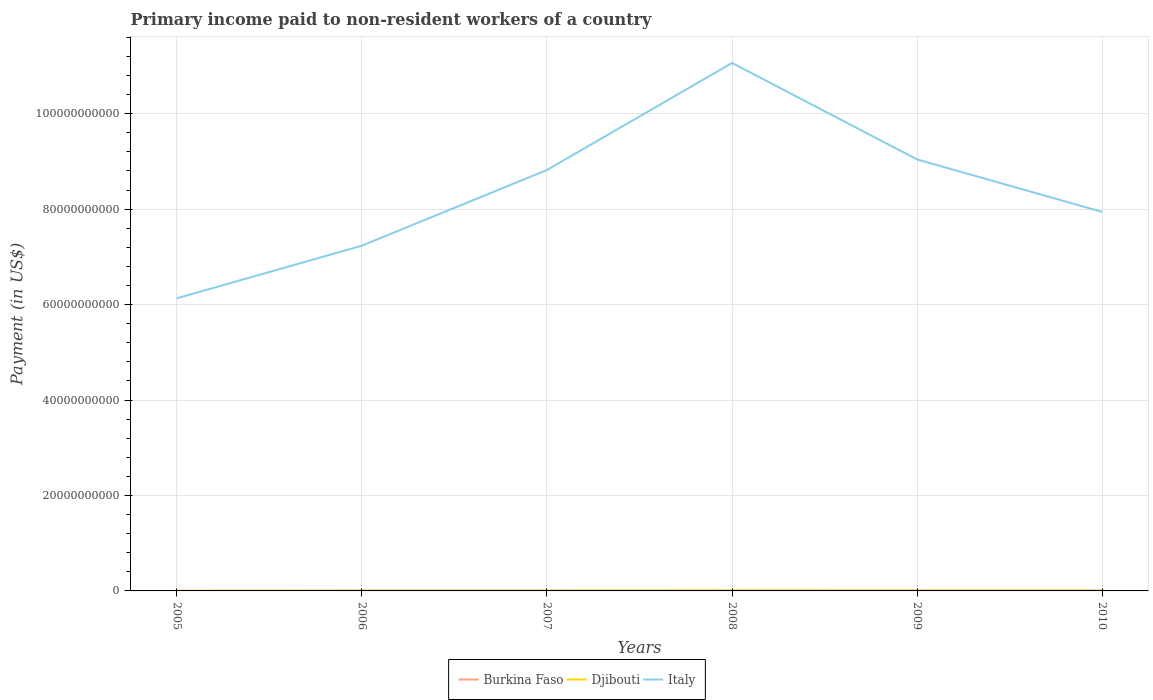How many different coloured lines are there?
Make the answer very short. 3. Across all years, what is the maximum amount paid to workers in Burkina Faso?
Your response must be concise. 3.80e+07. What is the total amount paid to workers in Burkina Faso in the graph?
Provide a short and direct response. -2.83e+07. What is the difference between the highest and the second highest amount paid to workers in Burkina Faso?
Offer a terse response. 5.37e+07. What is the difference between the highest and the lowest amount paid to workers in Italy?
Ensure brevity in your answer.  3. How many years are there in the graph?
Provide a succinct answer. 6. Are the values on the major ticks of Y-axis written in scientific E-notation?
Offer a terse response. No. Does the graph contain grids?
Provide a short and direct response. Yes. Where does the legend appear in the graph?
Your response must be concise. Bottom center. How many legend labels are there?
Offer a very short reply. 3. What is the title of the graph?
Your response must be concise. Primary income paid to non-resident workers of a country. What is the label or title of the X-axis?
Your response must be concise. Years. What is the label or title of the Y-axis?
Your answer should be very brief. Payment (in US$). What is the Payment (in US$) of Burkina Faso in 2005?
Give a very brief answer. 3.80e+07. What is the Payment (in US$) in Djibouti in 2005?
Provide a succinct answer. 3.20e+07. What is the Payment (in US$) of Italy in 2005?
Provide a succinct answer. 6.13e+1. What is the Payment (in US$) of Burkina Faso in 2006?
Keep it short and to the point. 6.05e+07. What is the Payment (in US$) in Djibouti in 2006?
Your response must be concise. 3.49e+07. What is the Payment (in US$) of Italy in 2006?
Offer a very short reply. 7.24e+1. What is the Payment (in US$) in Burkina Faso in 2007?
Keep it short and to the point. 6.34e+07. What is the Payment (in US$) of Djibouti in 2007?
Provide a succinct answer. 3.52e+07. What is the Payment (in US$) in Italy in 2007?
Provide a succinct answer. 8.82e+1. What is the Payment (in US$) of Burkina Faso in 2008?
Offer a very short reply. 8.53e+07. What is the Payment (in US$) of Djibouti in 2008?
Your response must be concise. 4.56e+07. What is the Payment (in US$) of Italy in 2008?
Ensure brevity in your answer.  1.11e+11. What is the Payment (in US$) in Burkina Faso in 2009?
Keep it short and to the point. 8.74e+07. What is the Payment (in US$) of Djibouti in 2009?
Keep it short and to the point. 3.70e+07. What is the Payment (in US$) of Italy in 2009?
Your answer should be compact. 9.04e+1. What is the Payment (in US$) in Burkina Faso in 2010?
Your answer should be compact. 9.17e+07. What is the Payment (in US$) in Djibouti in 2010?
Provide a succinct answer. 3.28e+07. What is the Payment (in US$) in Italy in 2010?
Offer a terse response. 7.94e+1. Across all years, what is the maximum Payment (in US$) of Burkina Faso?
Your response must be concise. 9.17e+07. Across all years, what is the maximum Payment (in US$) in Djibouti?
Your response must be concise. 4.56e+07. Across all years, what is the maximum Payment (in US$) of Italy?
Give a very brief answer. 1.11e+11. Across all years, what is the minimum Payment (in US$) of Burkina Faso?
Ensure brevity in your answer.  3.80e+07. Across all years, what is the minimum Payment (in US$) of Djibouti?
Your answer should be very brief. 3.20e+07. Across all years, what is the minimum Payment (in US$) of Italy?
Provide a short and direct response. 6.13e+1. What is the total Payment (in US$) in Burkina Faso in the graph?
Your response must be concise. 4.26e+08. What is the total Payment (in US$) in Djibouti in the graph?
Your answer should be very brief. 2.17e+08. What is the total Payment (in US$) of Italy in the graph?
Provide a succinct answer. 5.02e+11. What is the difference between the Payment (in US$) of Burkina Faso in 2005 and that in 2006?
Offer a terse response. -2.25e+07. What is the difference between the Payment (in US$) in Djibouti in 2005 and that in 2006?
Offer a terse response. -2.91e+06. What is the difference between the Payment (in US$) of Italy in 2005 and that in 2006?
Offer a terse response. -1.10e+1. What is the difference between the Payment (in US$) in Burkina Faso in 2005 and that in 2007?
Offer a terse response. -2.54e+07. What is the difference between the Payment (in US$) in Djibouti in 2005 and that in 2007?
Your response must be concise. -3.24e+06. What is the difference between the Payment (in US$) of Italy in 2005 and that in 2007?
Keep it short and to the point. -2.69e+1. What is the difference between the Payment (in US$) of Burkina Faso in 2005 and that in 2008?
Provide a succinct answer. -4.73e+07. What is the difference between the Payment (in US$) of Djibouti in 2005 and that in 2008?
Provide a short and direct response. -1.36e+07. What is the difference between the Payment (in US$) in Italy in 2005 and that in 2008?
Give a very brief answer. -4.93e+1. What is the difference between the Payment (in US$) of Burkina Faso in 2005 and that in 2009?
Provide a succinct answer. -4.94e+07. What is the difference between the Payment (in US$) in Djibouti in 2005 and that in 2009?
Offer a terse response. -5.00e+06. What is the difference between the Payment (in US$) of Italy in 2005 and that in 2009?
Give a very brief answer. -2.91e+1. What is the difference between the Payment (in US$) of Burkina Faso in 2005 and that in 2010?
Provide a short and direct response. -5.37e+07. What is the difference between the Payment (in US$) of Djibouti in 2005 and that in 2010?
Your answer should be very brief. -7.99e+05. What is the difference between the Payment (in US$) of Italy in 2005 and that in 2010?
Ensure brevity in your answer.  -1.81e+1. What is the difference between the Payment (in US$) of Burkina Faso in 2006 and that in 2007?
Keep it short and to the point. -2.89e+06. What is the difference between the Payment (in US$) of Djibouti in 2006 and that in 2007?
Provide a succinct answer. -3.32e+05. What is the difference between the Payment (in US$) in Italy in 2006 and that in 2007?
Keep it short and to the point. -1.59e+1. What is the difference between the Payment (in US$) in Burkina Faso in 2006 and that in 2008?
Provide a short and direct response. -2.48e+07. What is the difference between the Payment (in US$) in Djibouti in 2006 and that in 2008?
Provide a short and direct response. -1.07e+07. What is the difference between the Payment (in US$) in Italy in 2006 and that in 2008?
Your answer should be compact. -3.83e+1. What is the difference between the Payment (in US$) of Burkina Faso in 2006 and that in 2009?
Keep it short and to the point. -2.69e+07. What is the difference between the Payment (in US$) of Djibouti in 2006 and that in 2009?
Your answer should be compact. -2.09e+06. What is the difference between the Payment (in US$) of Italy in 2006 and that in 2009?
Your answer should be very brief. -1.81e+1. What is the difference between the Payment (in US$) of Burkina Faso in 2006 and that in 2010?
Provide a short and direct response. -3.12e+07. What is the difference between the Payment (in US$) of Djibouti in 2006 and that in 2010?
Your response must be concise. 2.11e+06. What is the difference between the Payment (in US$) of Italy in 2006 and that in 2010?
Ensure brevity in your answer.  -7.08e+09. What is the difference between the Payment (in US$) of Burkina Faso in 2007 and that in 2008?
Keep it short and to the point. -2.19e+07. What is the difference between the Payment (in US$) of Djibouti in 2007 and that in 2008?
Give a very brief answer. -1.04e+07. What is the difference between the Payment (in US$) of Italy in 2007 and that in 2008?
Offer a very short reply. -2.24e+1. What is the difference between the Payment (in US$) of Burkina Faso in 2007 and that in 2009?
Provide a succinct answer. -2.40e+07. What is the difference between the Payment (in US$) of Djibouti in 2007 and that in 2009?
Ensure brevity in your answer.  -1.76e+06. What is the difference between the Payment (in US$) of Italy in 2007 and that in 2009?
Your answer should be compact. -2.21e+09. What is the difference between the Payment (in US$) of Burkina Faso in 2007 and that in 2010?
Offer a very short reply. -2.83e+07. What is the difference between the Payment (in US$) in Djibouti in 2007 and that in 2010?
Provide a succinct answer. 2.44e+06. What is the difference between the Payment (in US$) in Italy in 2007 and that in 2010?
Provide a short and direct response. 8.79e+09. What is the difference between the Payment (in US$) of Burkina Faso in 2008 and that in 2009?
Ensure brevity in your answer.  -2.12e+06. What is the difference between the Payment (in US$) in Djibouti in 2008 and that in 2009?
Offer a terse response. 8.63e+06. What is the difference between the Payment (in US$) in Italy in 2008 and that in 2009?
Provide a short and direct response. 2.02e+1. What is the difference between the Payment (in US$) of Burkina Faso in 2008 and that in 2010?
Your answer should be very brief. -6.38e+06. What is the difference between the Payment (in US$) of Djibouti in 2008 and that in 2010?
Keep it short and to the point. 1.28e+07. What is the difference between the Payment (in US$) in Italy in 2008 and that in 2010?
Provide a short and direct response. 3.12e+1. What is the difference between the Payment (in US$) in Burkina Faso in 2009 and that in 2010?
Provide a short and direct response. -4.26e+06. What is the difference between the Payment (in US$) in Djibouti in 2009 and that in 2010?
Offer a terse response. 4.20e+06. What is the difference between the Payment (in US$) in Italy in 2009 and that in 2010?
Provide a short and direct response. 1.10e+1. What is the difference between the Payment (in US$) in Burkina Faso in 2005 and the Payment (in US$) in Djibouti in 2006?
Offer a terse response. 3.14e+06. What is the difference between the Payment (in US$) of Burkina Faso in 2005 and the Payment (in US$) of Italy in 2006?
Provide a short and direct response. -7.23e+1. What is the difference between the Payment (in US$) in Djibouti in 2005 and the Payment (in US$) in Italy in 2006?
Your response must be concise. -7.23e+1. What is the difference between the Payment (in US$) of Burkina Faso in 2005 and the Payment (in US$) of Djibouti in 2007?
Provide a succinct answer. 2.81e+06. What is the difference between the Payment (in US$) in Burkina Faso in 2005 and the Payment (in US$) in Italy in 2007?
Provide a short and direct response. -8.82e+1. What is the difference between the Payment (in US$) of Djibouti in 2005 and the Payment (in US$) of Italy in 2007?
Your response must be concise. -8.82e+1. What is the difference between the Payment (in US$) in Burkina Faso in 2005 and the Payment (in US$) in Djibouti in 2008?
Ensure brevity in your answer.  -7.58e+06. What is the difference between the Payment (in US$) of Burkina Faso in 2005 and the Payment (in US$) of Italy in 2008?
Your answer should be compact. -1.11e+11. What is the difference between the Payment (in US$) in Djibouti in 2005 and the Payment (in US$) in Italy in 2008?
Ensure brevity in your answer.  -1.11e+11. What is the difference between the Payment (in US$) of Burkina Faso in 2005 and the Payment (in US$) of Djibouti in 2009?
Offer a very short reply. 1.05e+06. What is the difference between the Payment (in US$) in Burkina Faso in 2005 and the Payment (in US$) in Italy in 2009?
Ensure brevity in your answer.  -9.04e+1. What is the difference between the Payment (in US$) in Djibouti in 2005 and the Payment (in US$) in Italy in 2009?
Make the answer very short. -9.04e+1. What is the difference between the Payment (in US$) of Burkina Faso in 2005 and the Payment (in US$) of Djibouti in 2010?
Offer a very short reply. 5.25e+06. What is the difference between the Payment (in US$) in Burkina Faso in 2005 and the Payment (in US$) in Italy in 2010?
Offer a terse response. -7.94e+1. What is the difference between the Payment (in US$) of Djibouti in 2005 and the Payment (in US$) of Italy in 2010?
Offer a very short reply. -7.94e+1. What is the difference between the Payment (in US$) of Burkina Faso in 2006 and the Payment (in US$) of Djibouti in 2007?
Your response must be concise. 2.53e+07. What is the difference between the Payment (in US$) of Burkina Faso in 2006 and the Payment (in US$) of Italy in 2007?
Provide a short and direct response. -8.82e+1. What is the difference between the Payment (in US$) in Djibouti in 2006 and the Payment (in US$) in Italy in 2007?
Make the answer very short. -8.82e+1. What is the difference between the Payment (in US$) in Burkina Faso in 2006 and the Payment (in US$) in Djibouti in 2008?
Make the answer very short. 1.49e+07. What is the difference between the Payment (in US$) in Burkina Faso in 2006 and the Payment (in US$) in Italy in 2008?
Your answer should be very brief. -1.11e+11. What is the difference between the Payment (in US$) in Djibouti in 2006 and the Payment (in US$) in Italy in 2008?
Offer a very short reply. -1.11e+11. What is the difference between the Payment (in US$) in Burkina Faso in 2006 and the Payment (in US$) in Djibouti in 2009?
Ensure brevity in your answer.  2.35e+07. What is the difference between the Payment (in US$) in Burkina Faso in 2006 and the Payment (in US$) in Italy in 2009?
Give a very brief answer. -9.04e+1. What is the difference between the Payment (in US$) of Djibouti in 2006 and the Payment (in US$) of Italy in 2009?
Offer a terse response. -9.04e+1. What is the difference between the Payment (in US$) of Burkina Faso in 2006 and the Payment (in US$) of Djibouti in 2010?
Your answer should be very brief. 2.77e+07. What is the difference between the Payment (in US$) of Burkina Faso in 2006 and the Payment (in US$) of Italy in 2010?
Provide a succinct answer. -7.94e+1. What is the difference between the Payment (in US$) in Djibouti in 2006 and the Payment (in US$) in Italy in 2010?
Offer a very short reply. -7.94e+1. What is the difference between the Payment (in US$) of Burkina Faso in 2007 and the Payment (in US$) of Djibouti in 2008?
Your response must be concise. 1.78e+07. What is the difference between the Payment (in US$) in Burkina Faso in 2007 and the Payment (in US$) in Italy in 2008?
Your answer should be compact. -1.11e+11. What is the difference between the Payment (in US$) of Djibouti in 2007 and the Payment (in US$) of Italy in 2008?
Make the answer very short. -1.11e+11. What is the difference between the Payment (in US$) of Burkina Faso in 2007 and the Payment (in US$) of Djibouti in 2009?
Provide a short and direct response. 2.64e+07. What is the difference between the Payment (in US$) in Burkina Faso in 2007 and the Payment (in US$) in Italy in 2009?
Offer a very short reply. -9.04e+1. What is the difference between the Payment (in US$) in Djibouti in 2007 and the Payment (in US$) in Italy in 2009?
Offer a terse response. -9.04e+1. What is the difference between the Payment (in US$) of Burkina Faso in 2007 and the Payment (in US$) of Djibouti in 2010?
Make the answer very short. 3.06e+07. What is the difference between the Payment (in US$) in Burkina Faso in 2007 and the Payment (in US$) in Italy in 2010?
Your answer should be very brief. -7.94e+1. What is the difference between the Payment (in US$) of Djibouti in 2007 and the Payment (in US$) of Italy in 2010?
Offer a very short reply. -7.94e+1. What is the difference between the Payment (in US$) in Burkina Faso in 2008 and the Payment (in US$) in Djibouti in 2009?
Your response must be concise. 4.83e+07. What is the difference between the Payment (in US$) of Burkina Faso in 2008 and the Payment (in US$) of Italy in 2009?
Offer a very short reply. -9.03e+1. What is the difference between the Payment (in US$) of Djibouti in 2008 and the Payment (in US$) of Italy in 2009?
Ensure brevity in your answer.  -9.04e+1. What is the difference between the Payment (in US$) in Burkina Faso in 2008 and the Payment (in US$) in Djibouti in 2010?
Make the answer very short. 5.25e+07. What is the difference between the Payment (in US$) in Burkina Faso in 2008 and the Payment (in US$) in Italy in 2010?
Provide a short and direct response. -7.93e+1. What is the difference between the Payment (in US$) in Djibouti in 2008 and the Payment (in US$) in Italy in 2010?
Offer a terse response. -7.94e+1. What is the difference between the Payment (in US$) of Burkina Faso in 2009 and the Payment (in US$) of Djibouti in 2010?
Your answer should be very brief. 5.47e+07. What is the difference between the Payment (in US$) in Burkina Faso in 2009 and the Payment (in US$) in Italy in 2010?
Provide a succinct answer. -7.93e+1. What is the difference between the Payment (in US$) of Djibouti in 2009 and the Payment (in US$) of Italy in 2010?
Ensure brevity in your answer.  -7.94e+1. What is the average Payment (in US$) in Burkina Faso per year?
Ensure brevity in your answer.  7.10e+07. What is the average Payment (in US$) of Djibouti per year?
Offer a very short reply. 3.62e+07. What is the average Payment (in US$) in Italy per year?
Provide a short and direct response. 8.37e+1. In the year 2005, what is the difference between the Payment (in US$) of Burkina Faso and Payment (in US$) of Djibouti?
Your response must be concise. 6.05e+06. In the year 2005, what is the difference between the Payment (in US$) of Burkina Faso and Payment (in US$) of Italy?
Provide a short and direct response. -6.13e+1. In the year 2005, what is the difference between the Payment (in US$) of Djibouti and Payment (in US$) of Italy?
Offer a terse response. -6.13e+1. In the year 2006, what is the difference between the Payment (in US$) of Burkina Faso and Payment (in US$) of Djibouti?
Ensure brevity in your answer.  2.56e+07. In the year 2006, what is the difference between the Payment (in US$) in Burkina Faso and Payment (in US$) in Italy?
Make the answer very short. -7.23e+1. In the year 2006, what is the difference between the Payment (in US$) of Djibouti and Payment (in US$) of Italy?
Give a very brief answer. -7.23e+1. In the year 2007, what is the difference between the Payment (in US$) in Burkina Faso and Payment (in US$) in Djibouti?
Provide a succinct answer. 2.82e+07. In the year 2007, what is the difference between the Payment (in US$) in Burkina Faso and Payment (in US$) in Italy?
Offer a terse response. -8.81e+1. In the year 2007, what is the difference between the Payment (in US$) in Djibouti and Payment (in US$) in Italy?
Offer a terse response. -8.82e+1. In the year 2008, what is the difference between the Payment (in US$) in Burkina Faso and Payment (in US$) in Djibouti?
Your answer should be very brief. 3.97e+07. In the year 2008, what is the difference between the Payment (in US$) in Burkina Faso and Payment (in US$) in Italy?
Your response must be concise. -1.11e+11. In the year 2008, what is the difference between the Payment (in US$) of Djibouti and Payment (in US$) of Italy?
Give a very brief answer. -1.11e+11. In the year 2009, what is the difference between the Payment (in US$) in Burkina Faso and Payment (in US$) in Djibouti?
Your answer should be very brief. 5.05e+07. In the year 2009, what is the difference between the Payment (in US$) of Burkina Faso and Payment (in US$) of Italy?
Your response must be concise. -9.03e+1. In the year 2009, what is the difference between the Payment (in US$) of Djibouti and Payment (in US$) of Italy?
Give a very brief answer. -9.04e+1. In the year 2010, what is the difference between the Payment (in US$) of Burkina Faso and Payment (in US$) of Djibouti?
Your response must be concise. 5.89e+07. In the year 2010, what is the difference between the Payment (in US$) in Burkina Faso and Payment (in US$) in Italy?
Your response must be concise. -7.93e+1. In the year 2010, what is the difference between the Payment (in US$) of Djibouti and Payment (in US$) of Italy?
Provide a short and direct response. -7.94e+1. What is the ratio of the Payment (in US$) of Burkina Faso in 2005 to that in 2006?
Offer a terse response. 0.63. What is the ratio of the Payment (in US$) of Djibouti in 2005 to that in 2006?
Your answer should be compact. 0.92. What is the ratio of the Payment (in US$) in Italy in 2005 to that in 2006?
Offer a terse response. 0.85. What is the ratio of the Payment (in US$) in Burkina Faso in 2005 to that in 2007?
Give a very brief answer. 0.6. What is the ratio of the Payment (in US$) of Djibouti in 2005 to that in 2007?
Make the answer very short. 0.91. What is the ratio of the Payment (in US$) of Italy in 2005 to that in 2007?
Your response must be concise. 0.7. What is the ratio of the Payment (in US$) in Burkina Faso in 2005 to that in 2008?
Your answer should be compact. 0.45. What is the ratio of the Payment (in US$) in Djibouti in 2005 to that in 2008?
Provide a short and direct response. 0.7. What is the ratio of the Payment (in US$) of Italy in 2005 to that in 2008?
Offer a very short reply. 0.55. What is the ratio of the Payment (in US$) in Burkina Faso in 2005 to that in 2009?
Keep it short and to the point. 0.43. What is the ratio of the Payment (in US$) in Djibouti in 2005 to that in 2009?
Provide a succinct answer. 0.86. What is the ratio of the Payment (in US$) of Italy in 2005 to that in 2009?
Offer a terse response. 0.68. What is the ratio of the Payment (in US$) of Burkina Faso in 2005 to that in 2010?
Your answer should be compact. 0.41. What is the ratio of the Payment (in US$) of Djibouti in 2005 to that in 2010?
Provide a succinct answer. 0.98. What is the ratio of the Payment (in US$) in Italy in 2005 to that in 2010?
Offer a terse response. 0.77. What is the ratio of the Payment (in US$) of Burkina Faso in 2006 to that in 2007?
Provide a short and direct response. 0.95. What is the ratio of the Payment (in US$) of Djibouti in 2006 to that in 2007?
Offer a terse response. 0.99. What is the ratio of the Payment (in US$) in Italy in 2006 to that in 2007?
Make the answer very short. 0.82. What is the ratio of the Payment (in US$) of Burkina Faso in 2006 to that in 2008?
Your response must be concise. 0.71. What is the ratio of the Payment (in US$) in Djibouti in 2006 to that in 2008?
Offer a very short reply. 0.76. What is the ratio of the Payment (in US$) of Italy in 2006 to that in 2008?
Keep it short and to the point. 0.65. What is the ratio of the Payment (in US$) of Burkina Faso in 2006 to that in 2009?
Provide a succinct answer. 0.69. What is the ratio of the Payment (in US$) in Djibouti in 2006 to that in 2009?
Your answer should be very brief. 0.94. What is the ratio of the Payment (in US$) in Italy in 2006 to that in 2009?
Your response must be concise. 0.8. What is the ratio of the Payment (in US$) of Burkina Faso in 2006 to that in 2010?
Offer a very short reply. 0.66. What is the ratio of the Payment (in US$) in Djibouti in 2006 to that in 2010?
Give a very brief answer. 1.06. What is the ratio of the Payment (in US$) of Italy in 2006 to that in 2010?
Provide a short and direct response. 0.91. What is the ratio of the Payment (in US$) of Burkina Faso in 2007 to that in 2008?
Offer a terse response. 0.74. What is the ratio of the Payment (in US$) in Djibouti in 2007 to that in 2008?
Make the answer very short. 0.77. What is the ratio of the Payment (in US$) in Italy in 2007 to that in 2008?
Provide a short and direct response. 0.8. What is the ratio of the Payment (in US$) in Burkina Faso in 2007 to that in 2009?
Offer a very short reply. 0.72. What is the ratio of the Payment (in US$) of Djibouti in 2007 to that in 2009?
Provide a succinct answer. 0.95. What is the ratio of the Payment (in US$) of Italy in 2007 to that in 2009?
Make the answer very short. 0.98. What is the ratio of the Payment (in US$) of Burkina Faso in 2007 to that in 2010?
Give a very brief answer. 0.69. What is the ratio of the Payment (in US$) of Djibouti in 2007 to that in 2010?
Make the answer very short. 1.07. What is the ratio of the Payment (in US$) in Italy in 2007 to that in 2010?
Provide a short and direct response. 1.11. What is the ratio of the Payment (in US$) in Burkina Faso in 2008 to that in 2009?
Offer a very short reply. 0.98. What is the ratio of the Payment (in US$) in Djibouti in 2008 to that in 2009?
Provide a succinct answer. 1.23. What is the ratio of the Payment (in US$) of Italy in 2008 to that in 2009?
Offer a terse response. 1.22. What is the ratio of the Payment (in US$) in Burkina Faso in 2008 to that in 2010?
Your answer should be very brief. 0.93. What is the ratio of the Payment (in US$) of Djibouti in 2008 to that in 2010?
Offer a very short reply. 1.39. What is the ratio of the Payment (in US$) of Italy in 2008 to that in 2010?
Give a very brief answer. 1.39. What is the ratio of the Payment (in US$) in Burkina Faso in 2009 to that in 2010?
Provide a short and direct response. 0.95. What is the ratio of the Payment (in US$) of Djibouti in 2009 to that in 2010?
Provide a short and direct response. 1.13. What is the ratio of the Payment (in US$) in Italy in 2009 to that in 2010?
Your answer should be compact. 1.14. What is the difference between the highest and the second highest Payment (in US$) in Burkina Faso?
Your answer should be compact. 4.26e+06. What is the difference between the highest and the second highest Payment (in US$) of Djibouti?
Your answer should be compact. 8.63e+06. What is the difference between the highest and the second highest Payment (in US$) in Italy?
Make the answer very short. 2.02e+1. What is the difference between the highest and the lowest Payment (in US$) of Burkina Faso?
Keep it short and to the point. 5.37e+07. What is the difference between the highest and the lowest Payment (in US$) in Djibouti?
Provide a succinct answer. 1.36e+07. What is the difference between the highest and the lowest Payment (in US$) in Italy?
Provide a short and direct response. 4.93e+1. 